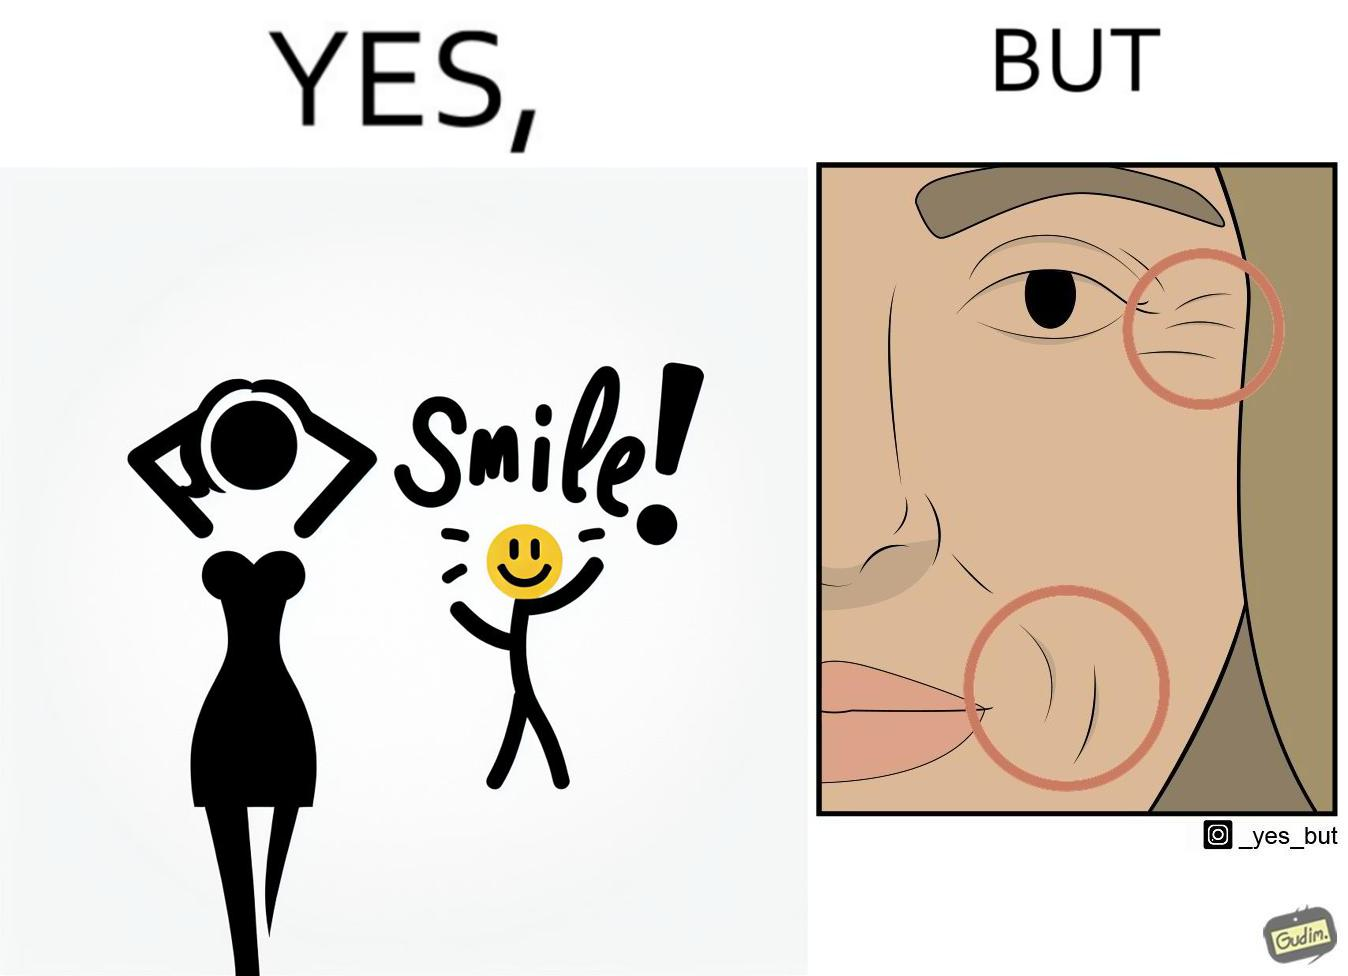Is this a satirical image? Yes, this image is satirical. 